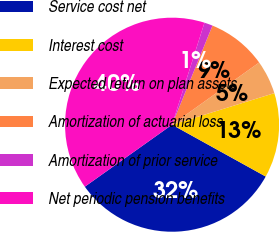<chart> <loc_0><loc_0><loc_500><loc_500><pie_chart><fcel>Service cost net<fcel>Interest cost<fcel>Expected return on plan assets<fcel>Amortization of actuarial loss<fcel>Amortization of prior service<fcel>Net periodic pension benefits<nl><fcel>32.12%<fcel>12.81%<fcel>5.11%<fcel>8.96%<fcel>1.27%<fcel>39.73%<nl></chart> 